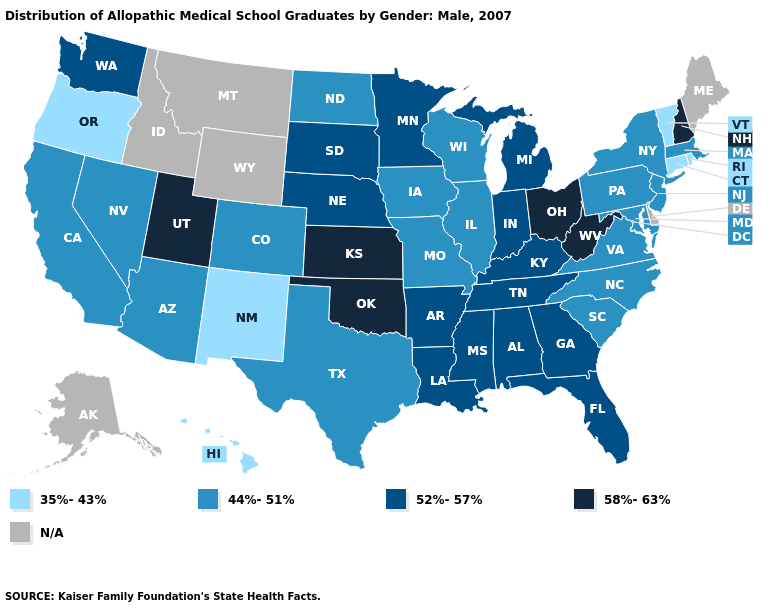What is the value of New Jersey?
Write a very short answer. 44%-51%. Among the states that border Utah , which have the lowest value?
Concise answer only. New Mexico. Which states have the lowest value in the USA?
Short answer required. Connecticut, Hawaii, New Mexico, Oregon, Rhode Island, Vermont. Among the states that border Ohio , does Michigan have the lowest value?
Concise answer only. No. Does Texas have the lowest value in the South?
Answer briefly. Yes. What is the highest value in the MidWest ?
Be succinct. 58%-63%. What is the value of Montana?
Keep it brief. N/A. What is the value of Utah?
Write a very short answer. 58%-63%. Among the states that border Wyoming , does Nebraska have the lowest value?
Concise answer only. No. What is the value of Missouri?
Be succinct. 44%-51%. Name the states that have a value in the range 35%-43%?
Quick response, please. Connecticut, Hawaii, New Mexico, Oregon, Rhode Island, Vermont. What is the lowest value in the USA?
Keep it brief. 35%-43%. Among the states that border Louisiana , which have the highest value?
Concise answer only. Arkansas, Mississippi. Which states have the highest value in the USA?
Keep it brief. Kansas, New Hampshire, Ohio, Oklahoma, Utah, West Virginia. 